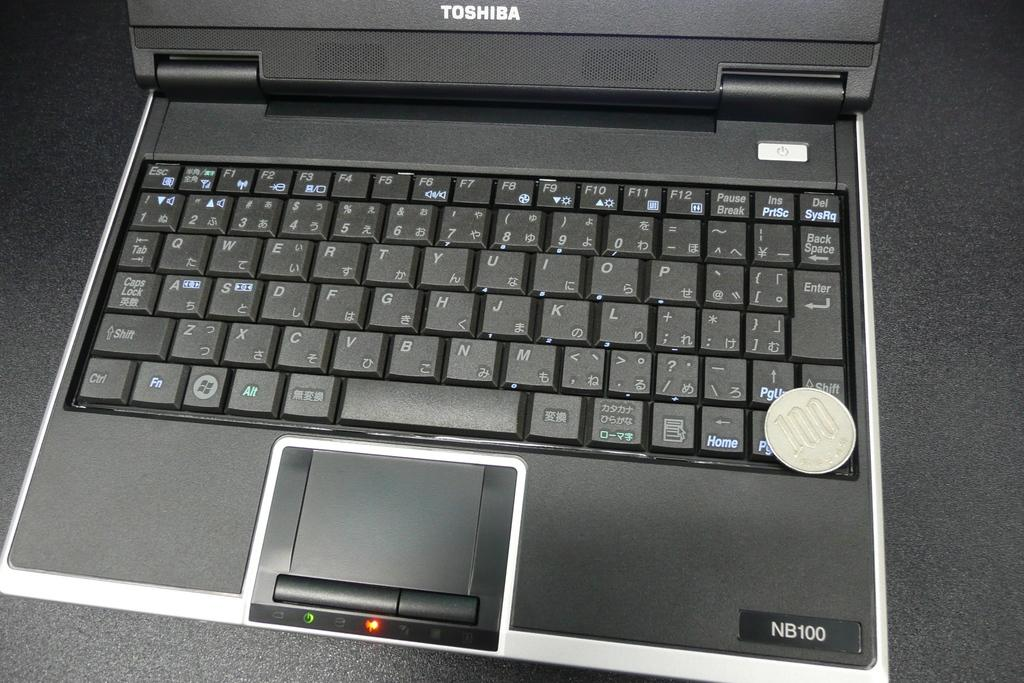<image>
Offer a succinct explanation of the picture presented. A Toshiba laptop is open and red and green lights are lit. 